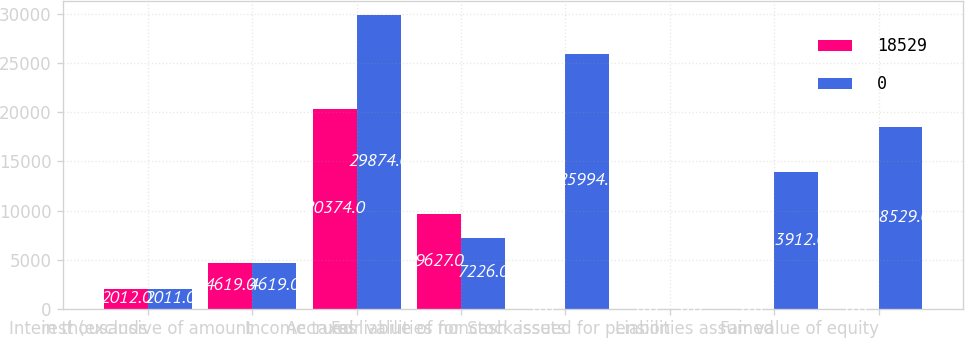Convert chart to OTSL. <chart><loc_0><loc_0><loc_500><loc_500><stacked_bar_chart><ecel><fcel>in thousands<fcel>Interest (exclusive of amount<fcel>Income taxes<fcel>Accrued liabilities for<fcel>Fair value of noncash assets<fcel>Stock issued for pension<fcel>Liabilities assumed<fcel>Fair value of equity<nl><fcel>18529<fcel>2012<fcel>4619<fcel>20374<fcel>9627<fcel>0<fcel>0<fcel>0<fcel>0<nl><fcel>0<fcel>2011<fcel>4619<fcel>29874<fcel>7226<fcel>25994<fcel>0<fcel>13912<fcel>18529<nl></chart> 